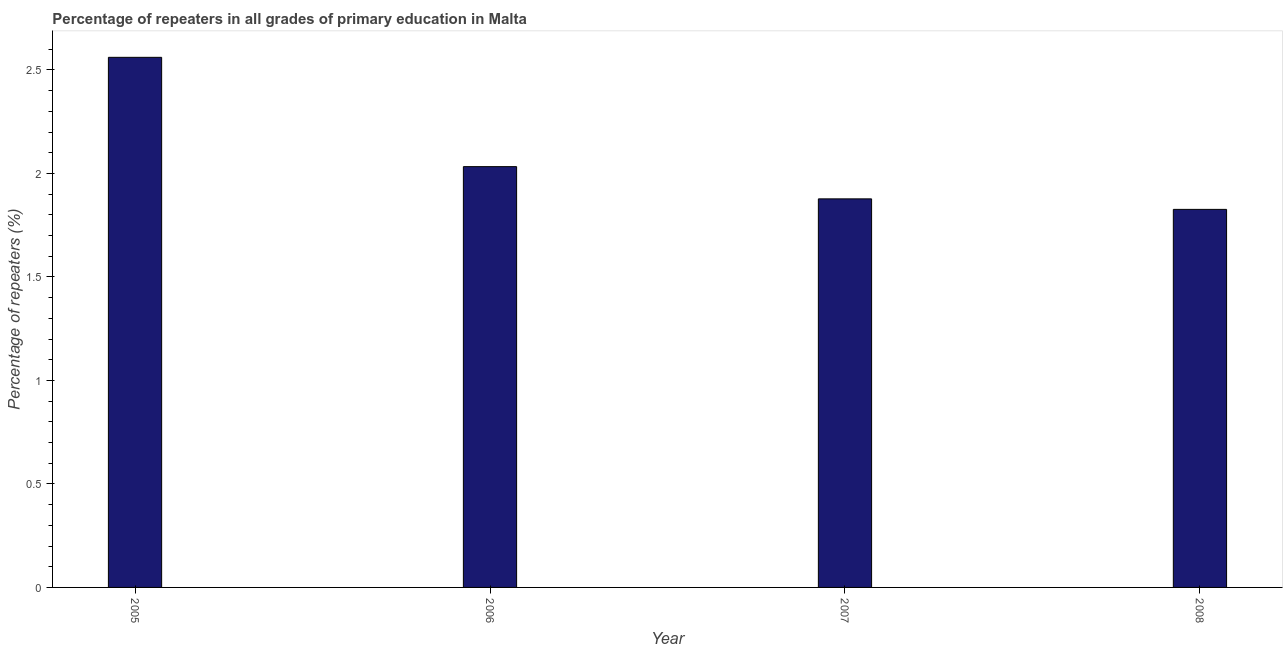Does the graph contain grids?
Offer a very short reply. No. What is the title of the graph?
Make the answer very short. Percentage of repeaters in all grades of primary education in Malta. What is the label or title of the X-axis?
Keep it short and to the point. Year. What is the label or title of the Y-axis?
Offer a very short reply. Percentage of repeaters (%). What is the percentage of repeaters in primary education in 2005?
Make the answer very short. 2.56. Across all years, what is the maximum percentage of repeaters in primary education?
Provide a short and direct response. 2.56. Across all years, what is the minimum percentage of repeaters in primary education?
Your answer should be very brief. 1.83. In which year was the percentage of repeaters in primary education maximum?
Offer a terse response. 2005. In which year was the percentage of repeaters in primary education minimum?
Provide a short and direct response. 2008. What is the sum of the percentage of repeaters in primary education?
Provide a succinct answer. 8.3. What is the difference between the percentage of repeaters in primary education in 2006 and 2007?
Make the answer very short. 0.16. What is the average percentage of repeaters in primary education per year?
Provide a short and direct response. 2.08. What is the median percentage of repeaters in primary education?
Ensure brevity in your answer.  1.96. In how many years, is the percentage of repeaters in primary education greater than 0.9 %?
Provide a short and direct response. 4. What is the ratio of the percentage of repeaters in primary education in 2007 to that in 2008?
Give a very brief answer. 1.03. What is the difference between the highest and the second highest percentage of repeaters in primary education?
Ensure brevity in your answer.  0.53. Is the sum of the percentage of repeaters in primary education in 2006 and 2007 greater than the maximum percentage of repeaters in primary education across all years?
Your answer should be very brief. Yes. What is the difference between the highest and the lowest percentage of repeaters in primary education?
Your answer should be compact. 0.73. In how many years, is the percentage of repeaters in primary education greater than the average percentage of repeaters in primary education taken over all years?
Offer a terse response. 1. Are all the bars in the graph horizontal?
Your answer should be very brief. No. How many years are there in the graph?
Your answer should be compact. 4. What is the difference between two consecutive major ticks on the Y-axis?
Make the answer very short. 0.5. What is the Percentage of repeaters (%) of 2005?
Your answer should be compact. 2.56. What is the Percentage of repeaters (%) of 2006?
Your response must be concise. 2.03. What is the Percentage of repeaters (%) in 2007?
Make the answer very short. 1.88. What is the Percentage of repeaters (%) of 2008?
Your answer should be compact. 1.83. What is the difference between the Percentage of repeaters (%) in 2005 and 2006?
Offer a terse response. 0.53. What is the difference between the Percentage of repeaters (%) in 2005 and 2007?
Make the answer very short. 0.68. What is the difference between the Percentage of repeaters (%) in 2005 and 2008?
Ensure brevity in your answer.  0.73. What is the difference between the Percentage of repeaters (%) in 2006 and 2007?
Make the answer very short. 0.16. What is the difference between the Percentage of repeaters (%) in 2006 and 2008?
Your answer should be very brief. 0.21. What is the difference between the Percentage of repeaters (%) in 2007 and 2008?
Make the answer very short. 0.05. What is the ratio of the Percentage of repeaters (%) in 2005 to that in 2006?
Offer a terse response. 1.26. What is the ratio of the Percentage of repeaters (%) in 2005 to that in 2007?
Keep it short and to the point. 1.36. What is the ratio of the Percentage of repeaters (%) in 2005 to that in 2008?
Provide a succinct answer. 1.4. What is the ratio of the Percentage of repeaters (%) in 2006 to that in 2007?
Make the answer very short. 1.08. What is the ratio of the Percentage of repeaters (%) in 2006 to that in 2008?
Ensure brevity in your answer.  1.11. What is the ratio of the Percentage of repeaters (%) in 2007 to that in 2008?
Provide a short and direct response. 1.03. 